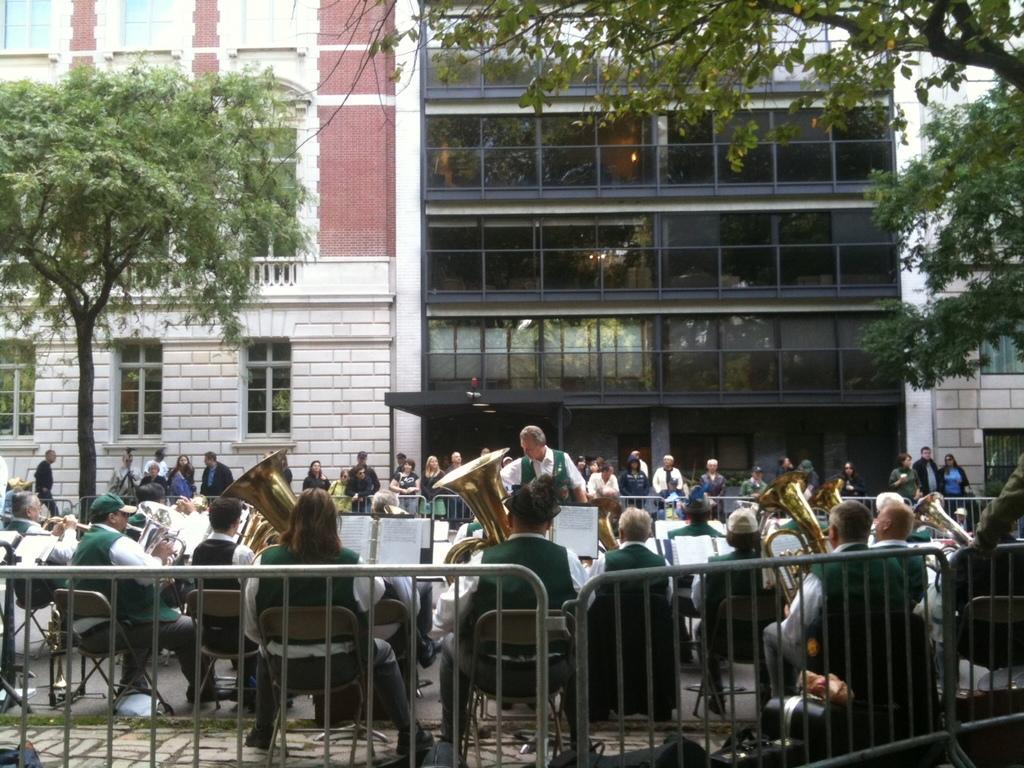Can you describe this image briefly? There is a group of people. They are playing a musical instruments. We can see the background is building and trees. 